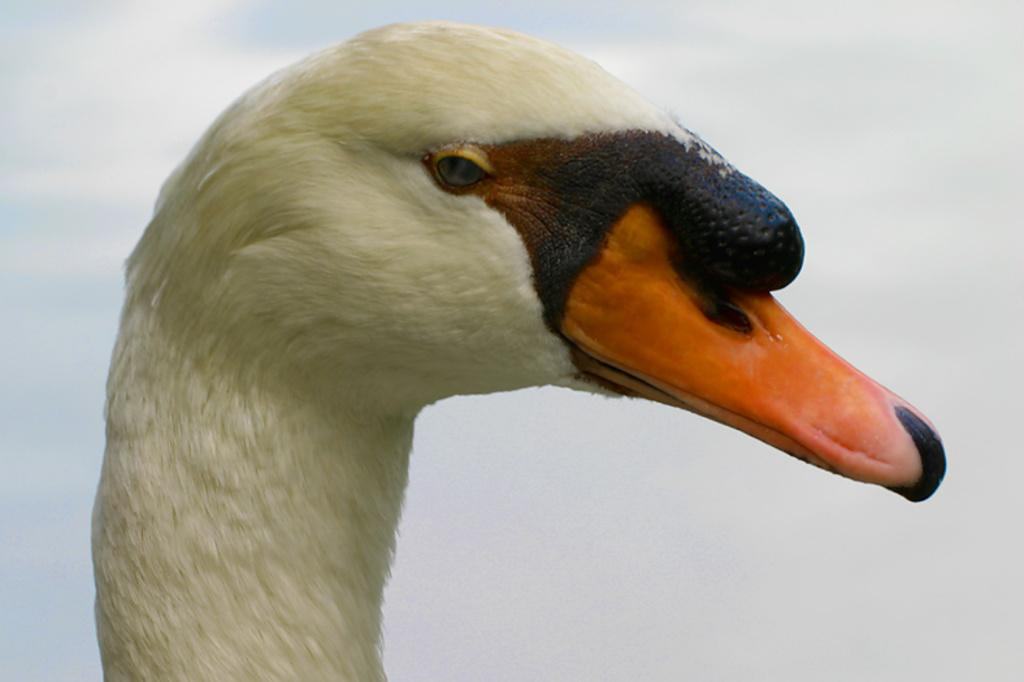What type of animal is in the image? There is a duck in the image. What color is the duck's beak? The duck has an orange color beak. What other color can be seen on the duck's head? Some parts of the duck's head are black in color. What type of hole can be seen in the duck's beak in the image? There is no hole visible in the duck's beak in the image. 